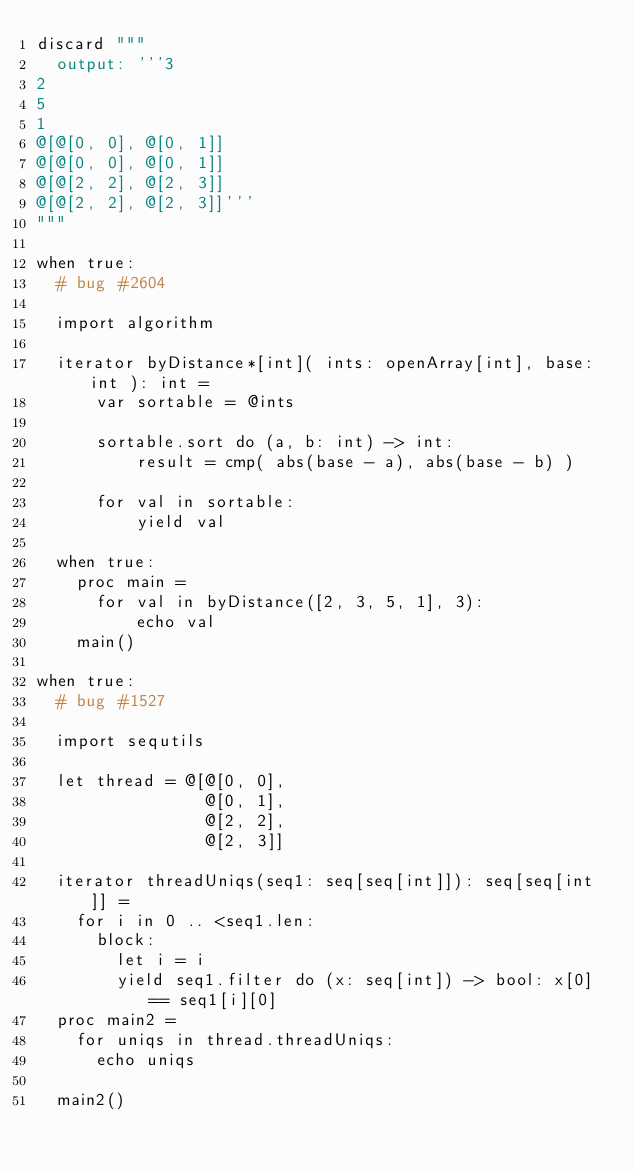<code> <loc_0><loc_0><loc_500><loc_500><_Nim_>discard """
  output: '''3
2
5
1
@[@[0, 0], @[0, 1]]
@[@[0, 0], @[0, 1]]
@[@[2, 2], @[2, 3]]
@[@[2, 2], @[2, 3]]'''
"""

when true:
  # bug #2604

  import algorithm

  iterator byDistance*[int]( ints: openArray[int], base: int ): int =
      var sortable = @ints

      sortable.sort do (a, b: int) -> int:
          result = cmp( abs(base - a), abs(base - b) )

      for val in sortable:
          yield val

  when true:
    proc main =
      for val in byDistance([2, 3, 5, 1], 3):
          echo val
    main()

when true:
  # bug #1527

  import sequtils

  let thread = @[@[0, 0],
                 @[0, 1],
                 @[2, 2],
                 @[2, 3]]

  iterator threadUniqs(seq1: seq[seq[int]]): seq[seq[int]] =
    for i in 0 .. <seq1.len:
      block:
        let i = i
        yield seq1.filter do (x: seq[int]) -> bool: x[0] == seq1[i][0]
  proc main2 =
    for uniqs in thread.threadUniqs:
      echo uniqs

  main2()
</code> 